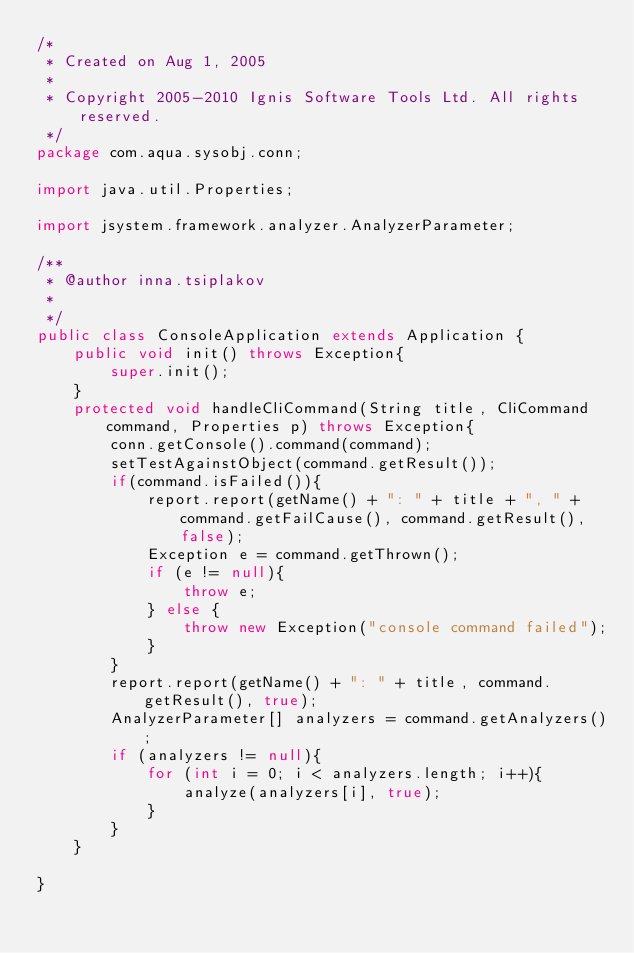<code> <loc_0><loc_0><loc_500><loc_500><_Java_>/*
 * Created on Aug 1, 2005
 * 
 * Copyright 2005-2010 Ignis Software Tools Ltd. All rights reserved.
 */
package com.aqua.sysobj.conn;

import java.util.Properties;

import jsystem.framework.analyzer.AnalyzerParameter;

/**
 * @author inna.tsiplakov
 *
 */
public class ConsoleApplication extends Application {
	public void init() throws Exception{
		super.init();
	}
	protected void handleCliCommand(String title, CliCommand command, Properties p) throws Exception{
		conn.getConsole().command(command);
		setTestAgainstObject(command.getResult());
		if(command.isFailed()){
			report.report(getName() + ": " + title + ", " + command.getFailCause(), command.getResult(), false);
			Exception e = command.getThrown();
			if (e != null){
				throw e;
			} else {
				throw new Exception("console command failed");
			}
		}
		report.report(getName() + ": " + title, command.getResult(), true);
		AnalyzerParameter[] analyzers = command.getAnalyzers();
		if (analyzers != null){
			for (int i = 0; i < analyzers.length; i++){
				analyze(analyzers[i], true);
			}
		}
	}

}
</code> 